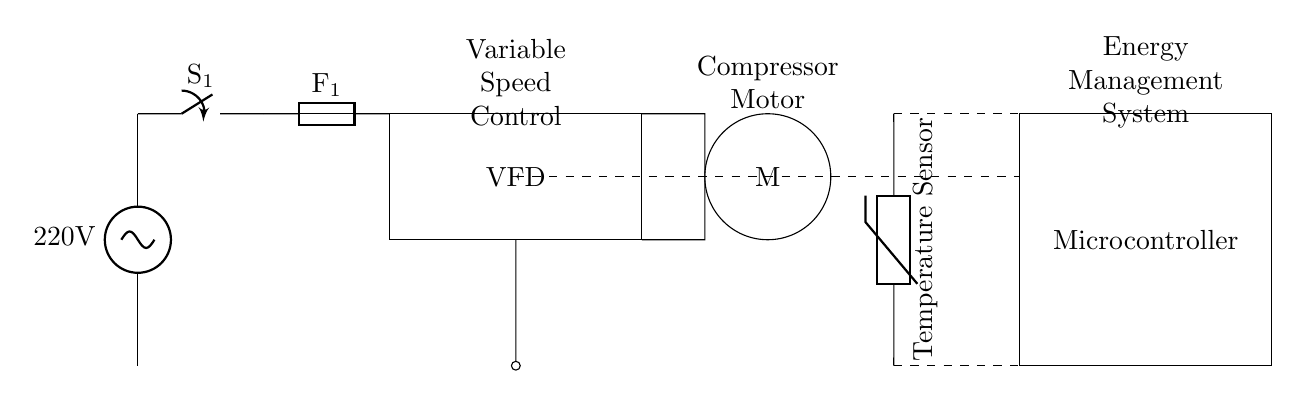What is the voltage of this circuit? The circuit is powered by a supply of 220 volts, as indicated by the power source in the diagram.
Answer: 220 volts What component regulates the compressor motor speed? The Variable Frequency Drive (VFD) is responsible for controlling the speed of the compressor motor by varying the frequency of the electrical supply.
Answer: VFD How many main components are shown in the circuit? The main components include the power supply, main switch, fuse, VFD, compressor motor, temperature sensor, and microcontroller, totaling seven components.
Answer: Seven What role does the temperature sensor play in this circuit? The temperature sensor monitors the temperature inside the refrigerator and provides feedback to the microcontroller to adjust the compressor's operation accordingly, ensuring optimal cooling.
Answer: Feedback for cooling Which component provides the control logic for the circuit? The microcontroller processes the information from the temperature sensor and adjusts the operation of the VFD based on the cooling requirements.
Answer: Microcontroller What happens if the fuse fails? If the fuse blows, it interrupts the electrical circuit and protects other components from potential damage caused by overload or short circuits, effectively cutting off power to the entire system.
Answer: Power interruption 